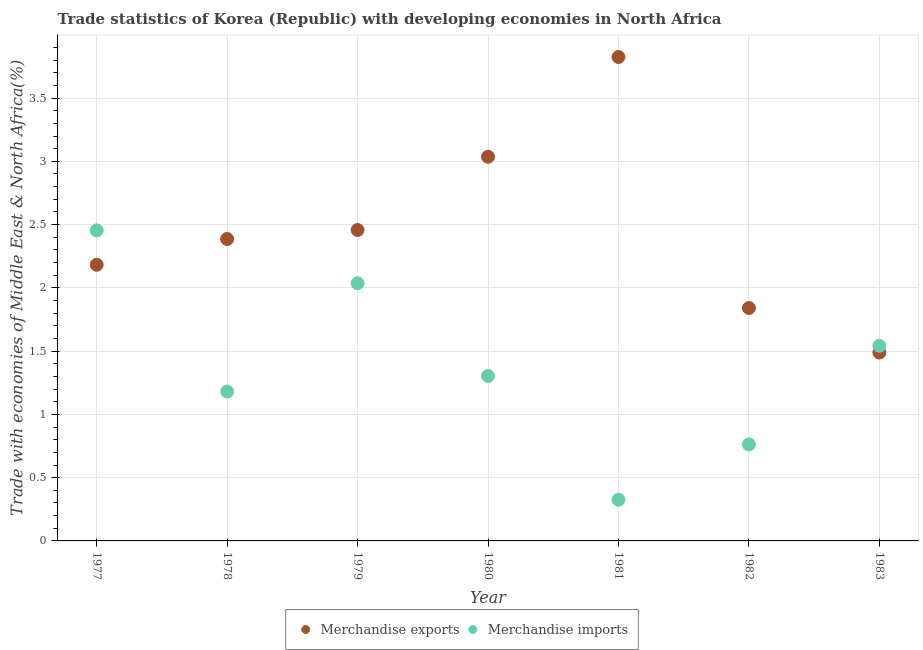What is the merchandise imports in 1982?
Your response must be concise. 0.76. Across all years, what is the maximum merchandise exports?
Make the answer very short. 3.82. Across all years, what is the minimum merchandise exports?
Make the answer very short. 1.49. In which year was the merchandise imports maximum?
Give a very brief answer. 1977. What is the total merchandise imports in the graph?
Provide a short and direct response. 9.6. What is the difference between the merchandise exports in 1977 and that in 1980?
Offer a very short reply. -0.85. What is the difference between the merchandise imports in 1981 and the merchandise exports in 1978?
Keep it short and to the point. -2.06. What is the average merchandise exports per year?
Your response must be concise. 2.46. In the year 1983, what is the difference between the merchandise exports and merchandise imports?
Give a very brief answer. -0.05. What is the ratio of the merchandise exports in 1978 to that in 1979?
Provide a short and direct response. 0.97. Is the difference between the merchandise exports in 1978 and 1983 greater than the difference between the merchandise imports in 1978 and 1983?
Your answer should be very brief. Yes. What is the difference between the highest and the second highest merchandise imports?
Your answer should be compact. 0.42. What is the difference between the highest and the lowest merchandise exports?
Make the answer very short. 2.34. In how many years, is the merchandise exports greater than the average merchandise exports taken over all years?
Make the answer very short. 2. Does the merchandise imports monotonically increase over the years?
Offer a terse response. No. Is the merchandise exports strictly less than the merchandise imports over the years?
Offer a terse response. No. What is the difference between two consecutive major ticks on the Y-axis?
Offer a very short reply. 0.5. How many legend labels are there?
Offer a very short reply. 2. How are the legend labels stacked?
Your answer should be compact. Horizontal. What is the title of the graph?
Provide a succinct answer. Trade statistics of Korea (Republic) with developing economies in North Africa. Does "Birth rate" appear as one of the legend labels in the graph?
Ensure brevity in your answer.  No. What is the label or title of the Y-axis?
Provide a short and direct response. Trade with economies of Middle East & North Africa(%). What is the Trade with economies of Middle East & North Africa(%) in Merchandise exports in 1977?
Give a very brief answer. 2.18. What is the Trade with economies of Middle East & North Africa(%) in Merchandise imports in 1977?
Provide a short and direct response. 2.45. What is the Trade with economies of Middle East & North Africa(%) of Merchandise exports in 1978?
Make the answer very short. 2.39. What is the Trade with economies of Middle East & North Africa(%) of Merchandise imports in 1978?
Provide a succinct answer. 1.18. What is the Trade with economies of Middle East & North Africa(%) in Merchandise exports in 1979?
Your response must be concise. 2.46. What is the Trade with economies of Middle East & North Africa(%) in Merchandise imports in 1979?
Your answer should be compact. 2.04. What is the Trade with economies of Middle East & North Africa(%) in Merchandise exports in 1980?
Ensure brevity in your answer.  3.04. What is the Trade with economies of Middle East & North Africa(%) in Merchandise imports in 1980?
Make the answer very short. 1.3. What is the Trade with economies of Middle East & North Africa(%) of Merchandise exports in 1981?
Provide a succinct answer. 3.82. What is the Trade with economies of Middle East & North Africa(%) of Merchandise imports in 1981?
Ensure brevity in your answer.  0.33. What is the Trade with economies of Middle East & North Africa(%) in Merchandise exports in 1982?
Offer a terse response. 1.84. What is the Trade with economies of Middle East & North Africa(%) in Merchandise imports in 1982?
Your answer should be compact. 0.76. What is the Trade with economies of Middle East & North Africa(%) in Merchandise exports in 1983?
Provide a short and direct response. 1.49. What is the Trade with economies of Middle East & North Africa(%) of Merchandise imports in 1983?
Provide a short and direct response. 1.54. Across all years, what is the maximum Trade with economies of Middle East & North Africa(%) in Merchandise exports?
Keep it short and to the point. 3.82. Across all years, what is the maximum Trade with economies of Middle East & North Africa(%) of Merchandise imports?
Keep it short and to the point. 2.45. Across all years, what is the minimum Trade with economies of Middle East & North Africa(%) in Merchandise exports?
Provide a short and direct response. 1.49. Across all years, what is the minimum Trade with economies of Middle East & North Africa(%) in Merchandise imports?
Offer a very short reply. 0.33. What is the total Trade with economies of Middle East & North Africa(%) in Merchandise exports in the graph?
Your answer should be compact. 17.22. What is the total Trade with economies of Middle East & North Africa(%) in Merchandise imports in the graph?
Offer a very short reply. 9.6. What is the difference between the Trade with economies of Middle East & North Africa(%) of Merchandise exports in 1977 and that in 1978?
Your response must be concise. -0.2. What is the difference between the Trade with economies of Middle East & North Africa(%) of Merchandise imports in 1977 and that in 1978?
Your answer should be compact. 1.27. What is the difference between the Trade with economies of Middle East & North Africa(%) in Merchandise exports in 1977 and that in 1979?
Make the answer very short. -0.27. What is the difference between the Trade with economies of Middle East & North Africa(%) in Merchandise imports in 1977 and that in 1979?
Offer a very short reply. 0.42. What is the difference between the Trade with economies of Middle East & North Africa(%) of Merchandise exports in 1977 and that in 1980?
Provide a succinct answer. -0.85. What is the difference between the Trade with economies of Middle East & North Africa(%) in Merchandise imports in 1977 and that in 1980?
Make the answer very short. 1.15. What is the difference between the Trade with economies of Middle East & North Africa(%) in Merchandise exports in 1977 and that in 1981?
Give a very brief answer. -1.64. What is the difference between the Trade with economies of Middle East & North Africa(%) in Merchandise imports in 1977 and that in 1981?
Offer a terse response. 2.13. What is the difference between the Trade with economies of Middle East & North Africa(%) in Merchandise exports in 1977 and that in 1982?
Provide a short and direct response. 0.34. What is the difference between the Trade with economies of Middle East & North Africa(%) of Merchandise imports in 1977 and that in 1982?
Provide a succinct answer. 1.69. What is the difference between the Trade with economies of Middle East & North Africa(%) in Merchandise exports in 1977 and that in 1983?
Keep it short and to the point. 0.69. What is the difference between the Trade with economies of Middle East & North Africa(%) of Merchandise imports in 1977 and that in 1983?
Provide a short and direct response. 0.91. What is the difference between the Trade with economies of Middle East & North Africa(%) in Merchandise exports in 1978 and that in 1979?
Provide a succinct answer. -0.07. What is the difference between the Trade with economies of Middle East & North Africa(%) in Merchandise imports in 1978 and that in 1979?
Your answer should be compact. -0.86. What is the difference between the Trade with economies of Middle East & North Africa(%) of Merchandise exports in 1978 and that in 1980?
Your answer should be very brief. -0.65. What is the difference between the Trade with economies of Middle East & North Africa(%) in Merchandise imports in 1978 and that in 1980?
Your answer should be compact. -0.12. What is the difference between the Trade with economies of Middle East & North Africa(%) of Merchandise exports in 1978 and that in 1981?
Your response must be concise. -1.44. What is the difference between the Trade with economies of Middle East & North Africa(%) in Merchandise imports in 1978 and that in 1981?
Your answer should be very brief. 0.85. What is the difference between the Trade with economies of Middle East & North Africa(%) of Merchandise exports in 1978 and that in 1982?
Give a very brief answer. 0.55. What is the difference between the Trade with economies of Middle East & North Africa(%) in Merchandise imports in 1978 and that in 1982?
Offer a terse response. 0.42. What is the difference between the Trade with economies of Middle East & North Africa(%) in Merchandise exports in 1978 and that in 1983?
Provide a short and direct response. 0.9. What is the difference between the Trade with economies of Middle East & North Africa(%) of Merchandise imports in 1978 and that in 1983?
Offer a terse response. -0.36. What is the difference between the Trade with economies of Middle East & North Africa(%) in Merchandise exports in 1979 and that in 1980?
Offer a terse response. -0.58. What is the difference between the Trade with economies of Middle East & North Africa(%) of Merchandise imports in 1979 and that in 1980?
Provide a short and direct response. 0.73. What is the difference between the Trade with economies of Middle East & North Africa(%) in Merchandise exports in 1979 and that in 1981?
Keep it short and to the point. -1.37. What is the difference between the Trade with economies of Middle East & North Africa(%) of Merchandise imports in 1979 and that in 1981?
Provide a short and direct response. 1.71. What is the difference between the Trade with economies of Middle East & North Africa(%) in Merchandise exports in 1979 and that in 1982?
Offer a terse response. 0.62. What is the difference between the Trade with economies of Middle East & North Africa(%) in Merchandise imports in 1979 and that in 1982?
Keep it short and to the point. 1.27. What is the difference between the Trade with economies of Middle East & North Africa(%) of Merchandise exports in 1979 and that in 1983?
Your response must be concise. 0.97. What is the difference between the Trade with economies of Middle East & North Africa(%) in Merchandise imports in 1979 and that in 1983?
Keep it short and to the point. 0.49. What is the difference between the Trade with economies of Middle East & North Africa(%) in Merchandise exports in 1980 and that in 1981?
Make the answer very short. -0.79. What is the difference between the Trade with economies of Middle East & North Africa(%) in Merchandise imports in 1980 and that in 1981?
Provide a short and direct response. 0.98. What is the difference between the Trade with economies of Middle East & North Africa(%) of Merchandise exports in 1980 and that in 1982?
Give a very brief answer. 1.2. What is the difference between the Trade with economies of Middle East & North Africa(%) of Merchandise imports in 1980 and that in 1982?
Provide a succinct answer. 0.54. What is the difference between the Trade with economies of Middle East & North Africa(%) in Merchandise exports in 1980 and that in 1983?
Your response must be concise. 1.55. What is the difference between the Trade with economies of Middle East & North Africa(%) of Merchandise imports in 1980 and that in 1983?
Make the answer very short. -0.24. What is the difference between the Trade with economies of Middle East & North Africa(%) in Merchandise exports in 1981 and that in 1982?
Offer a terse response. 1.98. What is the difference between the Trade with economies of Middle East & North Africa(%) in Merchandise imports in 1981 and that in 1982?
Provide a short and direct response. -0.44. What is the difference between the Trade with economies of Middle East & North Africa(%) in Merchandise exports in 1981 and that in 1983?
Ensure brevity in your answer.  2.34. What is the difference between the Trade with economies of Middle East & North Africa(%) in Merchandise imports in 1981 and that in 1983?
Offer a very short reply. -1.22. What is the difference between the Trade with economies of Middle East & North Africa(%) in Merchandise exports in 1982 and that in 1983?
Your answer should be very brief. 0.35. What is the difference between the Trade with economies of Middle East & North Africa(%) in Merchandise imports in 1982 and that in 1983?
Your answer should be very brief. -0.78. What is the difference between the Trade with economies of Middle East & North Africa(%) in Merchandise exports in 1977 and the Trade with economies of Middle East & North Africa(%) in Merchandise imports in 1979?
Offer a terse response. 0.15. What is the difference between the Trade with economies of Middle East & North Africa(%) of Merchandise exports in 1977 and the Trade with economies of Middle East & North Africa(%) of Merchandise imports in 1980?
Ensure brevity in your answer.  0.88. What is the difference between the Trade with economies of Middle East & North Africa(%) of Merchandise exports in 1977 and the Trade with economies of Middle East & North Africa(%) of Merchandise imports in 1981?
Offer a very short reply. 1.86. What is the difference between the Trade with economies of Middle East & North Africa(%) of Merchandise exports in 1977 and the Trade with economies of Middle East & North Africa(%) of Merchandise imports in 1982?
Keep it short and to the point. 1.42. What is the difference between the Trade with economies of Middle East & North Africa(%) of Merchandise exports in 1977 and the Trade with economies of Middle East & North Africa(%) of Merchandise imports in 1983?
Provide a succinct answer. 0.64. What is the difference between the Trade with economies of Middle East & North Africa(%) of Merchandise exports in 1978 and the Trade with economies of Middle East & North Africa(%) of Merchandise imports in 1979?
Your response must be concise. 0.35. What is the difference between the Trade with economies of Middle East & North Africa(%) of Merchandise exports in 1978 and the Trade with economies of Middle East & North Africa(%) of Merchandise imports in 1980?
Make the answer very short. 1.08. What is the difference between the Trade with economies of Middle East & North Africa(%) of Merchandise exports in 1978 and the Trade with economies of Middle East & North Africa(%) of Merchandise imports in 1981?
Offer a terse response. 2.06. What is the difference between the Trade with economies of Middle East & North Africa(%) of Merchandise exports in 1978 and the Trade with economies of Middle East & North Africa(%) of Merchandise imports in 1982?
Your answer should be very brief. 1.62. What is the difference between the Trade with economies of Middle East & North Africa(%) in Merchandise exports in 1978 and the Trade with economies of Middle East & North Africa(%) in Merchandise imports in 1983?
Your response must be concise. 0.84. What is the difference between the Trade with economies of Middle East & North Africa(%) of Merchandise exports in 1979 and the Trade with economies of Middle East & North Africa(%) of Merchandise imports in 1980?
Give a very brief answer. 1.15. What is the difference between the Trade with economies of Middle East & North Africa(%) of Merchandise exports in 1979 and the Trade with economies of Middle East & North Africa(%) of Merchandise imports in 1981?
Offer a very short reply. 2.13. What is the difference between the Trade with economies of Middle East & North Africa(%) in Merchandise exports in 1979 and the Trade with economies of Middle East & North Africa(%) in Merchandise imports in 1982?
Offer a terse response. 1.69. What is the difference between the Trade with economies of Middle East & North Africa(%) in Merchandise exports in 1979 and the Trade with economies of Middle East & North Africa(%) in Merchandise imports in 1983?
Your answer should be very brief. 0.92. What is the difference between the Trade with economies of Middle East & North Africa(%) of Merchandise exports in 1980 and the Trade with economies of Middle East & North Africa(%) of Merchandise imports in 1981?
Keep it short and to the point. 2.71. What is the difference between the Trade with economies of Middle East & North Africa(%) in Merchandise exports in 1980 and the Trade with economies of Middle East & North Africa(%) in Merchandise imports in 1982?
Ensure brevity in your answer.  2.27. What is the difference between the Trade with economies of Middle East & North Africa(%) of Merchandise exports in 1980 and the Trade with economies of Middle East & North Africa(%) of Merchandise imports in 1983?
Give a very brief answer. 1.49. What is the difference between the Trade with economies of Middle East & North Africa(%) of Merchandise exports in 1981 and the Trade with economies of Middle East & North Africa(%) of Merchandise imports in 1982?
Ensure brevity in your answer.  3.06. What is the difference between the Trade with economies of Middle East & North Africa(%) of Merchandise exports in 1981 and the Trade with economies of Middle East & North Africa(%) of Merchandise imports in 1983?
Your answer should be compact. 2.28. What is the difference between the Trade with economies of Middle East & North Africa(%) in Merchandise exports in 1982 and the Trade with economies of Middle East & North Africa(%) in Merchandise imports in 1983?
Offer a terse response. 0.3. What is the average Trade with economies of Middle East & North Africa(%) in Merchandise exports per year?
Give a very brief answer. 2.46. What is the average Trade with economies of Middle East & North Africa(%) in Merchandise imports per year?
Provide a succinct answer. 1.37. In the year 1977, what is the difference between the Trade with economies of Middle East & North Africa(%) of Merchandise exports and Trade with economies of Middle East & North Africa(%) of Merchandise imports?
Offer a terse response. -0.27. In the year 1978, what is the difference between the Trade with economies of Middle East & North Africa(%) in Merchandise exports and Trade with economies of Middle East & North Africa(%) in Merchandise imports?
Provide a succinct answer. 1.21. In the year 1979, what is the difference between the Trade with economies of Middle East & North Africa(%) of Merchandise exports and Trade with economies of Middle East & North Africa(%) of Merchandise imports?
Give a very brief answer. 0.42. In the year 1980, what is the difference between the Trade with economies of Middle East & North Africa(%) of Merchandise exports and Trade with economies of Middle East & North Africa(%) of Merchandise imports?
Give a very brief answer. 1.73. In the year 1981, what is the difference between the Trade with economies of Middle East & North Africa(%) in Merchandise exports and Trade with economies of Middle East & North Africa(%) in Merchandise imports?
Your answer should be compact. 3.5. In the year 1982, what is the difference between the Trade with economies of Middle East & North Africa(%) in Merchandise exports and Trade with economies of Middle East & North Africa(%) in Merchandise imports?
Ensure brevity in your answer.  1.08. In the year 1983, what is the difference between the Trade with economies of Middle East & North Africa(%) in Merchandise exports and Trade with economies of Middle East & North Africa(%) in Merchandise imports?
Make the answer very short. -0.05. What is the ratio of the Trade with economies of Middle East & North Africa(%) in Merchandise exports in 1977 to that in 1978?
Ensure brevity in your answer.  0.91. What is the ratio of the Trade with economies of Middle East & North Africa(%) in Merchandise imports in 1977 to that in 1978?
Your answer should be very brief. 2.08. What is the ratio of the Trade with economies of Middle East & North Africa(%) of Merchandise exports in 1977 to that in 1979?
Make the answer very short. 0.89. What is the ratio of the Trade with economies of Middle East & North Africa(%) of Merchandise imports in 1977 to that in 1979?
Provide a succinct answer. 1.21. What is the ratio of the Trade with economies of Middle East & North Africa(%) in Merchandise exports in 1977 to that in 1980?
Keep it short and to the point. 0.72. What is the ratio of the Trade with economies of Middle East & North Africa(%) in Merchandise imports in 1977 to that in 1980?
Provide a short and direct response. 1.88. What is the ratio of the Trade with economies of Middle East & North Africa(%) of Merchandise exports in 1977 to that in 1981?
Offer a terse response. 0.57. What is the ratio of the Trade with economies of Middle East & North Africa(%) in Merchandise imports in 1977 to that in 1981?
Your response must be concise. 7.53. What is the ratio of the Trade with economies of Middle East & North Africa(%) of Merchandise exports in 1977 to that in 1982?
Provide a short and direct response. 1.19. What is the ratio of the Trade with economies of Middle East & North Africa(%) of Merchandise imports in 1977 to that in 1982?
Give a very brief answer. 3.22. What is the ratio of the Trade with economies of Middle East & North Africa(%) of Merchandise exports in 1977 to that in 1983?
Provide a short and direct response. 1.47. What is the ratio of the Trade with economies of Middle East & North Africa(%) of Merchandise imports in 1977 to that in 1983?
Provide a short and direct response. 1.59. What is the ratio of the Trade with economies of Middle East & North Africa(%) in Merchandise exports in 1978 to that in 1979?
Provide a succinct answer. 0.97. What is the ratio of the Trade with economies of Middle East & North Africa(%) in Merchandise imports in 1978 to that in 1979?
Offer a terse response. 0.58. What is the ratio of the Trade with economies of Middle East & North Africa(%) of Merchandise exports in 1978 to that in 1980?
Your answer should be very brief. 0.79. What is the ratio of the Trade with economies of Middle East & North Africa(%) in Merchandise imports in 1978 to that in 1980?
Your answer should be very brief. 0.91. What is the ratio of the Trade with economies of Middle East & North Africa(%) in Merchandise exports in 1978 to that in 1981?
Provide a short and direct response. 0.62. What is the ratio of the Trade with economies of Middle East & North Africa(%) in Merchandise imports in 1978 to that in 1981?
Your response must be concise. 3.62. What is the ratio of the Trade with economies of Middle East & North Africa(%) of Merchandise exports in 1978 to that in 1982?
Keep it short and to the point. 1.3. What is the ratio of the Trade with economies of Middle East & North Africa(%) in Merchandise imports in 1978 to that in 1982?
Keep it short and to the point. 1.55. What is the ratio of the Trade with economies of Middle East & North Africa(%) in Merchandise exports in 1978 to that in 1983?
Your response must be concise. 1.6. What is the ratio of the Trade with economies of Middle East & North Africa(%) of Merchandise imports in 1978 to that in 1983?
Ensure brevity in your answer.  0.77. What is the ratio of the Trade with economies of Middle East & North Africa(%) of Merchandise exports in 1979 to that in 1980?
Your answer should be compact. 0.81. What is the ratio of the Trade with economies of Middle East & North Africa(%) in Merchandise imports in 1979 to that in 1980?
Your response must be concise. 1.56. What is the ratio of the Trade with economies of Middle East & North Africa(%) in Merchandise exports in 1979 to that in 1981?
Offer a terse response. 0.64. What is the ratio of the Trade with economies of Middle East & North Africa(%) of Merchandise imports in 1979 to that in 1981?
Your answer should be very brief. 6.25. What is the ratio of the Trade with economies of Middle East & North Africa(%) of Merchandise exports in 1979 to that in 1982?
Keep it short and to the point. 1.33. What is the ratio of the Trade with economies of Middle East & North Africa(%) in Merchandise imports in 1979 to that in 1982?
Your answer should be compact. 2.67. What is the ratio of the Trade with economies of Middle East & North Africa(%) in Merchandise exports in 1979 to that in 1983?
Ensure brevity in your answer.  1.65. What is the ratio of the Trade with economies of Middle East & North Africa(%) in Merchandise imports in 1979 to that in 1983?
Offer a terse response. 1.32. What is the ratio of the Trade with economies of Middle East & North Africa(%) in Merchandise exports in 1980 to that in 1981?
Your response must be concise. 0.79. What is the ratio of the Trade with economies of Middle East & North Africa(%) in Merchandise imports in 1980 to that in 1981?
Offer a terse response. 4. What is the ratio of the Trade with economies of Middle East & North Africa(%) in Merchandise exports in 1980 to that in 1982?
Your response must be concise. 1.65. What is the ratio of the Trade with economies of Middle East & North Africa(%) in Merchandise imports in 1980 to that in 1982?
Provide a short and direct response. 1.71. What is the ratio of the Trade with economies of Middle East & North Africa(%) in Merchandise exports in 1980 to that in 1983?
Ensure brevity in your answer.  2.04. What is the ratio of the Trade with economies of Middle East & North Africa(%) in Merchandise imports in 1980 to that in 1983?
Offer a terse response. 0.85. What is the ratio of the Trade with economies of Middle East & North Africa(%) in Merchandise exports in 1981 to that in 1982?
Give a very brief answer. 2.08. What is the ratio of the Trade with economies of Middle East & North Africa(%) of Merchandise imports in 1981 to that in 1982?
Offer a very short reply. 0.43. What is the ratio of the Trade with economies of Middle East & North Africa(%) in Merchandise exports in 1981 to that in 1983?
Offer a very short reply. 2.57. What is the ratio of the Trade with economies of Middle East & North Africa(%) of Merchandise imports in 1981 to that in 1983?
Your answer should be very brief. 0.21. What is the ratio of the Trade with economies of Middle East & North Africa(%) of Merchandise exports in 1982 to that in 1983?
Your response must be concise. 1.24. What is the ratio of the Trade with economies of Middle East & North Africa(%) in Merchandise imports in 1982 to that in 1983?
Offer a terse response. 0.49. What is the difference between the highest and the second highest Trade with economies of Middle East & North Africa(%) in Merchandise exports?
Ensure brevity in your answer.  0.79. What is the difference between the highest and the second highest Trade with economies of Middle East & North Africa(%) of Merchandise imports?
Your answer should be compact. 0.42. What is the difference between the highest and the lowest Trade with economies of Middle East & North Africa(%) in Merchandise exports?
Offer a very short reply. 2.34. What is the difference between the highest and the lowest Trade with economies of Middle East & North Africa(%) of Merchandise imports?
Make the answer very short. 2.13. 